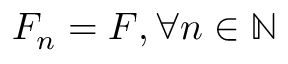<formula> <loc_0><loc_0><loc_500><loc_500>F _ { n } = F , \forall n \in \mathbb { N }</formula> 